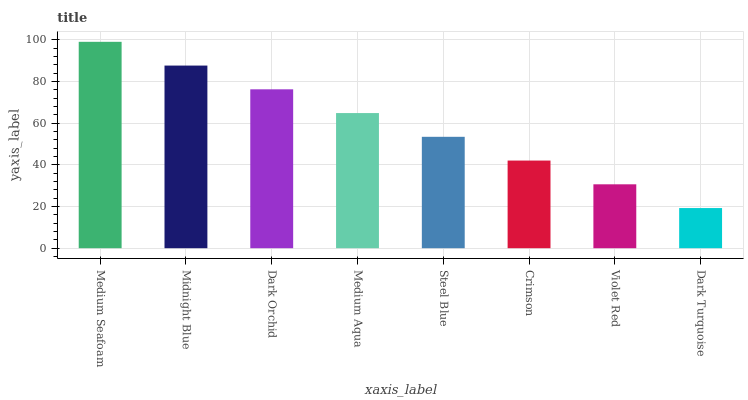Is Dark Turquoise the minimum?
Answer yes or no. Yes. Is Medium Seafoam the maximum?
Answer yes or no. Yes. Is Midnight Blue the minimum?
Answer yes or no. No. Is Midnight Blue the maximum?
Answer yes or no. No. Is Medium Seafoam greater than Midnight Blue?
Answer yes or no. Yes. Is Midnight Blue less than Medium Seafoam?
Answer yes or no. Yes. Is Midnight Blue greater than Medium Seafoam?
Answer yes or no. No. Is Medium Seafoam less than Midnight Blue?
Answer yes or no. No. Is Medium Aqua the high median?
Answer yes or no. Yes. Is Steel Blue the low median?
Answer yes or no. Yes. Is Violet Red the high median?
Answer yes or no. No. Is Midnight Blue the low median?
Answer yes or no. No. 